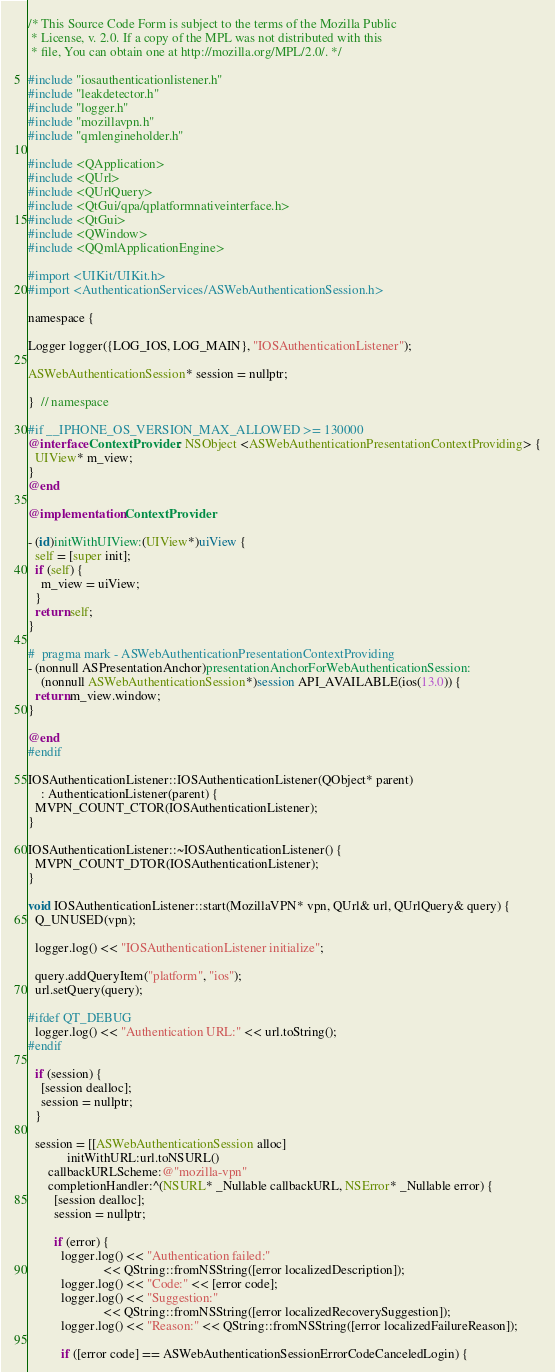<code> <loc_0><loc_0><loc_500><loc_500><_ObjectiveC_>/* This Source Code Form is subject to the terms of the Mozilla Public
 * License, v. 2.0. If a copy of the MPL was not distributed with this
 * file, You can obtain one at http://mozilla.org/MPL/2.0/. */

#include "iosauthenticationlistener.h"
#include "leakdetector.h"
#include "logger.h"
#include "mozillavpn.h"
#include "qmlengineholder.h"

#include <QApplication>
#include <QUrl>
#include <QUrlQuery>
#include <QtGui/qpa/qplatformnativeinterface.h>
#include <QtGui>
#include <QWindow>
#include <QQmlApplicationEngine>

#import <UIKit/UIKit.h>
#import <AuthenticationServices/ASWebAuthenticationSession.h>

namespace {

Logger logger({LOG_IOS, LOG_MAIN}, "IOSAuthenticationListener");

ASWebAuthenticationSession* session = nullptr;

}  // namespace

#if __IPHONE_OS_VERSION_MAX_ALLOWED >= 130000
@interface ContextProvider : NSObject <ASWebAuthenticationPresentationContextProviding> {
  UIView* m_view;
}
@end

@implementation ContextProvider

- (id)initWithUIView:(UIView*)uiView {
  self = [super init];
  if (self) {
    m_view = uiView;
  }
  return self;
}

#  pragma mark - ASWebAuthenticationPresentationContextProviding
- (nonnull ASPresentationAnchor)presentationAnchorForWebAuthenticationSession:
    (nonnull ASWebAuthenticationSession*)session API_AVAILABLE(ios(13.0)) {
  return m_view.window;
}

@end
#endif

IOSAuthenticationListener::IOSAuthenticationListener(QObject* parent)
    : AuthenticationListener(parent) {
  MVPN_COUNT_CTOR(IOSAuthenticationListener);
}

IOSAuthenticationListener::~IOSAuthenticationListener() {
  MVPN_COUNT_DTOR(IOSAuthenticationListener);
}

void IOSAuthenticationListener::start(MozillaVPN* vpn, QUrl& url, QUrlQuery& query) {
  Q_UNUSED(vpn);

  logger.log() << "IOSAuthenticationListener initialize";

  query.addQueryItem("platform", "ios");
  url.setQuery(query);

#ifdef QT_DEBUG
  logger.log() << "Authentication URL:" << url.toString();
#endif

  if (session) {
    [session dealloc];
    session = nullptr;
  }

  session = [[ASWebAuthenticationSession alloc]
            initWithURL:url.toNSURL()
      callbackURLScheme:@"mozilla-vpn"
      completionHandler:^(NSURL* _Nullable callbackURL, NSError* _Nullable error) {
        [session dealloc];
        session = nullptr;

        if (error) {
          logger.log() << "Authentication failed:"
                       << QString::fromNSString([error localizedDescription]);
          logger.log() << "Code:" << [error code];
          logger.log() << "Suggestion:"
                       << QString::fromNSString([error localizedRecoverySuggestion]);
          logger.log() << "Reason:" << QString::fromNSString([error localizedFailureReason]);

          if ([error code] == ASWebAuthenticationSessionErrorCodeCanceledLogin) {</code> 